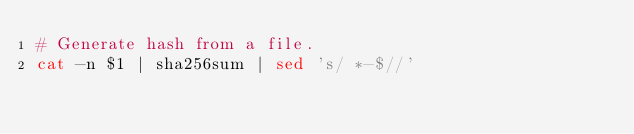<code> <loc_0><loc_0><loc_500><loc_500><_Bash_># Generate hash from a file.
cat -n $1 | sha256sum | sed 's/ *-$//'</code> 